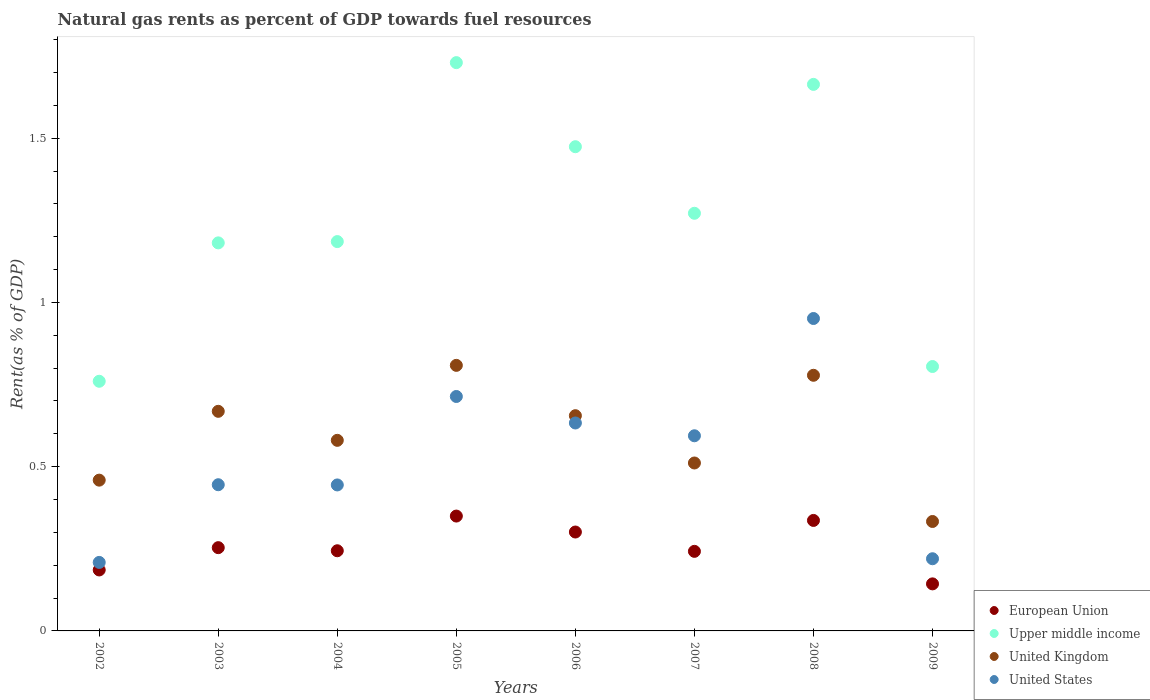How many different coloured dotlines are there?
Provide a succinct answer. 4. What is the matural gas rent in United Kingdom in 2004?
Give a very brief answer. 0.58. Across all years, what is the maximum matural gas rent in United Kingdom?
Ensure brevity in your answer.  0.81. Across all years, what is the minimum matural gas rent in European Union?
Your response must be concise. 0.14. What is the total matural gas rent in Upper middle income in the graph?
Offer a very short reply. 10.07. What is the difference between the matural gas rent in Upper middle income in 2006 and that in 2009?
Keep it short and to the point. 0.67. What is the difference between the matural gas rent in United States in 2002 and the matural gas rent in Upper middle income in 2003?
Provide a short and direct response. -0.97. What is the average matural gas rent in United Kingdom per year?
Offer a terse response. 0.6. In the year 2002, what is the difference between the matural gas rent in United States and matural gas rent in European Union?
Your answer should be very brief. 0.02. What is the ratio of the matural gas rent in United Kingdom in 2003 to that in 2009?
Offer a terse response. 2.01. Is the matural gas rent in United Kingdom in 2002 less than that in 2007?
Your answer should be very brief. Yes. What is the difference between the highest and the second highest matural gas rent in European Union?
Offer a terse response. 0.01. What is the difference between the highest and the lowest matural gas rent in United Kingdom?
Your answer should be very brief. 0.48. In how many years, is the matural gas rent in United States greater than the average matural gas rent in United States taken over all years?
Make the answer very short. 4. Is the sum of the matural gas rent in United States in 2002 and 2005 greater than the maximum matural gas rent in Upper middle income across all years?
Your answer should be compact. No. Is it the case that in every year, the sum of the matural gas rent in United States and matural gas rent in European Union  is greater than the sum of matural gas rent in United Kingdom and matural gas rent in Upper middle income?
Provide a short and direct response. No. Is it the case that in every year, the sum of the matural gas rent in Upper middle income and matural gas rent in European Union  is greater than the matural gas rent in United Kingdom?
Offer a very short reply. Yes. Does the matural gas rent in Upper middle income monotonically increase over the years?
Provide a succinct answer. No. Is the matural gas rent in United Kingdom strictly less than the matural gas rent in United States over the years?
Offer a very short reply. No. Are the values on the major ticks of Y-axis written in scientific E-notation?
Your answer should be compact. No. Where does the legend appear in the graph?
Provide a succinct answer. Bottom right. How many legend labels are there?
Give a very brief answer. 4. What is the title of the graph?
Offer a very short reply. Natural gas rents as percent of GDP towards fuel resources. Does "Guyana" appear as one of the legend labels in the graph?
Offer a very short reply. No. What is the label or title of the X-axis?
Give a very brief answer. Years. What is the label or title of the Y-axis?
Keep it short and to the point. Rent(as % of GDP). What is the Rent(as % of GDP) in European Union in 2002?
Offer a very short reply. 0.19. What is the Rent(as % of GDP) in Upper middle income in 2002?
Keep it short and to the point. 0.76. What is the Rent(as % of GDP) of United Kingdom in 2002?
Your response must be concise. 0.46. What is the Rent(as % of GDP) of United States in 2002?
Offer a terse response. 0.21. What is the Rent(as % of GDP) in European Union in 2003?
Your response must be concise. 0.25. What is the Rent(as % of GDP) in Upper middle income in 2003?
Offer a terse response. 1.18. What is the Rent(as % of GDP) of United Kingdom in 2003?
Provide a succinct answer. 0.67. What is the Rent(as % of GDP) in United States in 2003?
Provide a succinct answer. 0.45. What is the Rent(as % of GDP) of European Union in 2004?
Ensure brevity in your answer.  0.24. What is the Rent(as % of GDP) in Upper middle income in 2004?
Give a very brief answer. 1.19. What is the Rent(as % of GDP) of United Kingdom in 2004?
Make the answer very short. 0.58. What is the Rent(as % of GDP) of United States in 2004?
Offer a very short reply. 0.44. What is the Rent(as % of GDP) of European Union in 2005?
Keep it short and to the point. 0.35. What is the Rent(as % of GDP) of Upper middle income in 2005?
Your response must be concise. 1.73. What is the Rent(as % of GDP) of United Kingdom in 2005?
Offer a terse response. 0.81. What is the Rent(as % of GDP) of United States in 2005?
Provide a succinct answer. 0.71. What is the Rent(as % of GDP) in European Union in 2006?
Offer a very short reply. 0.3. What is the Rent(as % of GDP) in Upper middle income in 2006?
Provide a short and direct response. 1.47. What is the Rent(as % of GDP) in United Kingdom in 2006?
Offer a very short reply. 0.66. What is the Rent(as % of GDP) of United States in 2006?
Provide a succinct answer. 0.63. What is the Rent(as % of GDP) in European Union in 2007?
Offer a terse response. 0.24. What is the Rent(as % of GDP) in Upper middle income in 2007?
Provide a short and direct response. 1.27. What is the Rent(as % of GDP) of United Kingdom in 2007?
Ensure brevity in your answer.  0.51. What is the Rent(as % of GDP) of United States in 2007?
Make the answer very short. 0.59. What is the Rent(as % of GDP) of European Union in 2008?
Your response must be concise. 0.34. What is the Rent(as % of GDP) of Upper middle income in 2008?
Provide a short and direct response. 1.66. What is the Rent(as % of GDP) of United Kingdom in 2008?
Offer a very short reply. 0.78. What is the Rent(as % of GDP) in United States in 2008?
Give a very brief answer. 0.95. What is the Rent(as % of GDP) of European Union in 2009?
Your response must be concise. 0.14. What is the Rent(as % of GDP) of Upper middle income in 2009?
Keep it short and to the point. 0.8. What is the Rent(as % of GDP) of United Kingdom in 2009?
Give a very brief answer. 0.33. What is the Rent(as % of GDP) of United States in 2009?
Make the answer very short. 0.22. Across all years, what is the maximum Rent(as % of GDP) in European Union?
Provide a short and direct response. 0.35. Across all years, what is the maximum Rent(as % of GDP) of Upper middle income?
Make the answer very short. 1.73. Across all years, what is the maximum Rent(as % of GDP) of United Kingdom?
Give a very brief answer. 0.81. Across all years, what is the maximum Rent(as % of GDP) in United States?
Your answer should be compact. 0.95. Across all years, what is the minimum Rent(as % of GDP) in European Union?
Your answer should be compact. 0.14. Across all years, what is the minimum Rent(as % of GDP) of Upper middle income?
Make the answer very short. 0.76. Across all years, what is the minimum Rent(as % of GDP) of United Kingdom?
Your answer should be compact. 0.33. Across all years, what is the minimum Rent(as % of GDP) in United States?
Give a very brief answer. 0.21. What is the total Rent(as % of GDP) of European Union in the graph?
Provide a short and direct response. 2.06. What is the total Rent(as % of GDP) in Upper middle income in the graph?
Offer a very short reply. 10.07. What is the total Rent(as % of GDP) in United Kingdom in the graph?
Make the answer very short. 4.79. What is the total Rent(as % of GDP) in United States in the graph?
Ensure brevity in your answer.  4.21. What is the difference between the Rent(as % of GDP) in European Union in 2002 and that in 2003?
Ensure brevity in your answer.  -0.07. What is the difference between the Rent(as % of GDP) of Upper middle income in 2002 and that in 2003?
Offer a terse response. -0.42. What is the difference between the Rent(as % of GDP) in United Kingdom in 2002 and that in 2003?
Offer a terse response. -0.21. What is the difference between the Rent(as % of GDP) of United States in 2002 and that in 2003?
Your answer should be very brief. -0.24. What is the difference between the Rent(as % of GDP) of European Union in 2002 and that in 2004?
Keep it short and to the point. -0.06. What is the difference between the Rent(as % of GDP) in Upper middle income in 2002 and that in 2004?
Your answer should be compact. -0.43. What is the difference between the Rent(as % of GDP) of United Kingdom in 2002 and that in 2004?
Your answer should be very brief. -0.12. What is the difference between the Rent(as % of GDP) of United States in 2002 and that in 2004?
Offer a very short reply. -0.24. What is the difference between the Rent(as % of GDP) in European Union in 2002 and that in 2005?
Your response must be concise. -0.16. What is the difference between the Rent(as % of GDP) in Upper middle income in 2002 and that in 2005?
Ensure brevity in your answer.  -0.97. What is the difference between the Rent(as % of GDP) of United Kingdom in 2002 and that in 2005?
Give a very brief answer. -0.35. What is the difference between the Rent(as % of GDP) in United States in 2002 and that in 2005?
Provide a short and direct response. -0.51. What is the difference between the Rent(as % of GDP) of European Union in 2002 and that in 2006?
Provide a short and direct response. -0.12. What is the difference between the Rent(as % of GDP) of Upper middle income in 2002 and that in 2006?
Keep it short and to the point. -0.71. What is the difference between the Rent(as % of GDP) of United Kingdom in 2002 and that in 2006?
Give a very brief answer. -0.2. What is the difference between the Rent(as % of GDP) of United States in 2002 and that in 2006?
Provide a short and direct response. -0.42. What is the difference between the Rent(as % of GDP) in European Union in 2002 and that in 2007?
Your answer should be very brief. -0.06. What is the difference between the Rent(as % of GDP) in Upper middle income in 2002 and that in 2007?
Offer a terse response. -0.51. What is the difference between the Rent(as % of GDP) of United Kingdom in 2002 and that in 2007?
Provide a succinct answer. -0.05. What is the difference between the Rent(as % of GDP) of United States in 2002 and that in 2007?
Give a very brief answer. -0.39. What is the difference between the Rent(as % of GDP) in European Union in 2002 and that in 2008?
Your answer should be very brief. -0.15. What is the difference between the Rent(as % of GDP) of Upper middle income in 2002 and that in 2008?
Your answer should be very brief. -0.9. What is the difference between the Rent(as % of GDP) in United Kingdom in 2002 and that in 2008?
Offer a very short reply. -0.32. What is the difference between the Rent(as % of GDP) of United States in 2002 and that in 2008?
Provide a short and direct response. -0.74. What is the difference between the Rent(as % of GDP) in European Union in 2002 and that in 2009?
Give a very brief answer. 0.04. What is the difference between the Rent(as % of GDP) of Upper middle income in 2002 and that in 2009?
Make the answer very short. -0.04. What is the difference between the Rent(as % of GDP) of United Kingdom in 2002 and that in 2009?
Your answer should be very brief. 0.13. What is the difference between the Rent(as % of GDP) in United States in 2002 and that in 2009?
Provide a succinct answer. -0.01. What is the difference between the Rent(as % of GDP) in European Union in 2003 and that in 2004?
Keep it short and to the point. 0.01. What is the difference between the Rent(as % of GDP) in Upper middle income in 2003 and that in 2004?
Make the answer very short. -0. What is the difference between the Rent(as % of GDP) of United Kingdom in 2003 and that in 2004?
Offer a very short reply. 0.09. What is the difference between the Rent(as % of GDP) in United States in 2003 and that in 2004?
Provide a succinct answer. 0. What is the difference between the Rent(as % of GDP) in European Union in 2003 and that in 2005?
Your answer should be compact. -0.1. What is the difference between the Rent(as % of GDP) in Upper middle income in 2003 and that in 2005?
Make the answer very short. -0.55. What is the difference between the Rent(as % of GDP) in United Kingdom in 2003 and that in 2005?
Your answer should be compact. -0.14. What is the difference between the Rent(as % of GDP) in United States in 2003 and that in 2005?
Give a very brief answer. -0.27. What is the difference between the Rent(as % of GDP) in European Union in 2003 and that in 2006?
Provide a succinct answer. -0.05. What is the difference between the Rent(as % of GDP) of Upper middle income in 2003 and that in 2006?
Ensure brevity in your answer.  -0.29. What is the difference between the Rent(as % of GDP) of United Kingdom in 2003 and that in 2006?
Offer a very short reply. 0.01. What is the difference between the Rent(as % of GDP) in United States in 2003 and that in 2006?
Your answer should be compact. -0.19. What is the difference between the Rent(as % of GDP) in European Union in 2003 and that in 2007?
Make the answer very short. 0.01. What is the difference between the Rent(as % of GDP) in Upper middle income in 2003 and that in 2007?
Ensure brevity in your answer.  -0.09. What is the difference between the Rent(as % of GDP) of United Kingdom in 2003 and that in 2007?
Your answer should be compact. 0.16. What is the difference between the Rent(as % of GDP) of United States in 2003 and that in 2007?
Ensure brevity in your answer.  -0.15. What is the difference between the Rent(as % of GDP) of European Union in 2003 and that in 2008?
Offer a terse response. -0.08. What is the difference between the Rent(as % of GDP) of Upper middle income in 2003 and that in 2008?
Ensure brevity in your answer.  -0.48. What is the difference between the Rent(as % of GDP) of United Kingdom in 2003 and that in 2008?
Your answer should be compact. -0.11. What is the difference between the Rent(as % of GDP) of United States in 2003 and that in 2008?
Offer a terse response. -0.51. What is the difference between the Rent(as % of GDP) of European Union in 2003 and that in 2009?
Provide a short and direct response. 0.11. What is the difference between the Rent(as % of GDP) in Upper middle income in 2003 and that in 2009?
Keep it short and to the point. 0.38. What is the difference between the Rent(as % of GDP) in United Kingdom in 2003 and that in 2009?
Provide a short and direct response. 0.34. What is the difference between the Rent(as % of GDP) of United States in 2003 and that in 2009?
Offer a very short reply. 0.23. What is the difference between the Rent(as % of GDP) in European Union in 2004 and that in 2005?
Provide a short and direct response. -0.11. What is the difference between the Rent(as % of GDP) in Upper middle income in 2004 and that in 2005?
Give a very brief answer. -0.54. What is the difference between the Rent(as % of GDP) of United Kingdom in 2004 and that in 2005?
Keep it short and to the point. -0.23. What is the difference between the Rent(as % of GDP) of United States in 2004 and that in 2005?
Your answer should be compact. -0.27. What is the difference between the Rent(as % of GDP) of European Union in 2004 and that in 2006?
Your answer should be compact. -0.06. What is the difference between the Rent(as % of GDP) in Upper middle income in 2004 and that in 2006?
Make the answer very short. -0.29. What is the difference between the Rent(as % of GDP) of United Kingdom in 2004 and that in 2006?
Make the answer very short. -0.07. What is the difference between the Rent(as % of GDP) in United States in 2004 and that in 2006?
Your response must be concise. -0.19. What is the difference between the Rent(as % of GDP) in European Union in 2004 and that in 2007?
Keep it short and to the point. 0. What is the difference between the Rent(as % of GDP) of Upper middle income in 2004 and that in 2007?
Provide a succinct answer. -0.09. What is the difference between the Rent(as % of GDP) in United Kingdom in 2004 and that in 2007?
Provide a short and direct response. 0.07. What is the difference between the Rent(as % of GDP) of United States in 2004 and that in 2007?
Offer a very short reply. -0.15. What is the difference between the Rent(as % of GDP) in European Union in 2004 and that in 2008?
Offer a terse response. -0.09. What is the difference between the Rent(as % of GDP) in Upper middle income in 2004 and that in 2008?
Give a very brief answer. -0.48. What is the difference between the Rent(as % of GDP) in United Kingdom in 2004 and that in 2008?
Provide a succinct answer. -0.2. What is the difference between the Rent(as % of GDP) of United States in 2004 and that in 2008?
Make the answer very short. -0.51. What is the difference between the Rent(as % of GDP) in European Union in 2004 and that in 2009?
Give a very brief answer. 0.1. What is the difference between the Rent(as % of GDP) of Upper middle income in 2004 and that in 2009?
Give a very brief answer. 0.38. What is the difference between the Rent(as % of GDP) of United Kingdom in 2004 and that in 2009?
Ensure brevity in your answer.  0.25. What is the difference between the Rent(as % of GDP) of United States in 2004 and that in 2009?
Offer a terse response. 0.22. What is the difference between the Rent(as % of GDP) of European Union in 2005 and that in 2006?
Provide a short and direct response. 0.05. What is the difference between the Rent(as % of GDP) in Upper middle income in 2005 and that in 2006?
Provide a short and direct response. 0.26. What is the difference between the Rent(as % of GDP) in United Kingdom in 2005 and that in 2006?
Offer a terse response. 0.15. What is the difference between the Rent(as % of GDP) of United States in 2005 and that in 2006?
Provide a short and direct response. 0.08. What is the difference between the Rent(as % of GDP) of European Union in 2005 and that in 2007?
Your answer should be compact. 0.11. What is the difference between the Rent(as % of GDP) of Upper middle income in 2005 and that in 2007?
Ensure brevity in your answer.  0.46. What is the difference between the Rent(as % of GDP) of United Kingdom in 2005 and that in 2007?
Make the answer very short. 0.3. What is the difference between the Rent(as % of GDP) of United States in 2005 and that in 2007?
Keep it short and to the point. 0.12. What is the difference between the Rent(as % of GDP) of European Union in 2005 and that in 2008?
Give a very brief answer. 0.01. What is the difference between the Rent(as % of GDP) in Upper middle income in 2005 and that in 2008?
Ensure brevity in your answer.  0.07. What is the difference between the Rent(as % of GDP) of United Kingdom in 2005 and that in 2008?
Your answer should be very brief. 0.03. What is the difference between the Rent(as % of GDP) of United States in 2005 and that in 2008?
Your response must be concise. -0.24. What is the difference between the Rent(as % of GDP) of European Union in 2005 and that in 2009?
Ensure brevity in your answer.  0.21. What is the difference between the Rent(as % of GDP) in Upper middle income in 2005 and that in 2009?
Keep it short and to the point. 0.93. What is the difference between the Rent(as % of GDP) of United Kingdom in 2005 and that in 2009?
Your response must be concise. 0.48. What is the difference between the Rent(as % of GDP) in United States in 2005 and that in 2009?
Provide a short and direct response. 0.49. What is the difference between the Rent(as % of GDP) in European Union in 2006 and that in 2007?
Offer a terse response. 0.06. What is the difference between the Rent(as % of GDP) of Upper middle income in 2006 and that in 2007?
Your answer should be compact. 0.2. What is the difference between the Rent(as % of GDP) in United Kingdom in 2006 and that in 2007?
Provide a succinct answer. 0.14. What is the difference between the Rent(as % of GDP) in United States in 2006 and that in 2007?
Offer a terse response. 0.04. What is the difference between the Rent(as % of GDP) of European Union in 2006 and that in 2008?
Provide a short and direct response. -0.04. What is the difference between the Rent(as % of GDP) of Upper middle income in 2006 and that in 2008?
Offer a very short reply. -0.19. What is the difference between the Rent(as % of GDP) of United Kingdom in 2006 and that in 2008?
Provide a short and direct response. -0.12. What is the difference between the Rent(as % of GDP) in United States in 2006 and that in 2008?
Make the answer very short. -0.32. What is the difference between the Rent(as % of GDP) in European Union in 2006 and that in 2009?
Offer a terse response. 0.16. What is the difference between the Rent(as % of GDP) of Upper middle income in 2006 and that in 2009?
Offer a terse response. 0.67. What is the difference between the Rent(as % of GDP) in United Kingdom in 2006 and that in 2009?
Make the answer very short. 0.32. What is the difference between the Rent(as % of GDP) in United States in 2006 and that in 2009?
Offer a terse response. 0.41. What is the difference between the Rent(as % of GDP) in European Union in 2007 and that in 2008?
Keep it short and to the point. -0.09. What is the difference between the Rent(as % of GDP) of Upper middle income in 2007 and that in 2008?
Your response must be concise. -0.39. What is the difference between the Rent(as % of GDP) in United Kingdom in 2007 and that in 2008?
Your response must be concise. -0.27. What is the difference between the Rent(as % of GDP) in United States in 2007 and that in 2008?
Your response must be concise. -0.36. What is the difference between the Rent(as % of GDP) of European Union in 2007 and that in 2009?
Ensure brevity in your answer.  0.1. What is the difference between the Rent(as % of GDP) in Upper middle income in 2007 and that in 2009?
Your answer should be compact. 0.47. What is the difference between the Rent(as % of GDP) in United Kingdom in 2007 and that in 2009?
Provide a succinct answer. 0.18. What is the difference between the Rent(as % of GDP) of United States in 2007 and that in 2009?
Ensure brevity in your answer.  0.37. What is the difference between the Rent(as % of GDP) of European Union in 2008 and that in 2009?
Keep it short and to the point. 0.19. What is the difference between the Rent(as % of GDP) in Upper middle income in 2008 and that in 2009?
Your response must be concise. 0.86. What is the difference between the Rent(as % of GDP) in United Kingdom in 2008 and that in 2009?
Ensure brevity in your answer.  0.45. What is the difference between the Rent(as % of GDP) of United States in 2008 and that in 2009?
Your answer should be compact. 0.73. What is the difference between the Rent(as % of GDP) of European Union in 2002 and the Rent(as % of GDP) of Upper middle income in 2003?
Provide a short and direct response. -1. What is the difference between the Rent(as % of GDP) in European Union in 2002 and the Rent(as % of GDP) in United Kingdom in 2003?
Make the answer very short. -0.48. What is the difference between the Rent(as % of GDP) of European Union in 2002 and the Rent(as % of GDP) of United States in 2003?
Ensure brevity in your answer.  -0.26. What is the difference between the Rent(as % of GDP) in Upper middle income in 2002 and the Rent(as % of GDP) in United Kingdom in 2003?
Provide a succinct answer. 0.09. What is the difference between the Rent(as % of GDP) in Upper middle income in 2002 and the Rent(as % of GDP) in United States in 2003?
Provide a short and direct response. 0.32. What is the difference between the Rent(as % of GDP) of United Kingdom in 2002 and the Rent(as % of GDP) of United States in 2003?
Your response must be concise. 0.01. What is the difference between the Rent(as % of GDP) of European Union in 2002 and the Rent(as % of GDP) of Upper middle income in 2004?
Keep it short and to the point. -1. What is the difference between the Rent(as % of GDP) of European Union in 2002 and the Rent(as % of GDP) of United Kingdom in 2004?
Make the answer very short. -0.39. What is the difference between the Rent(as % of GDP) in European Union in 2002 and the Rent(as % of GDP) in United States in 2004?
Keep it short and to the point. -0.26. What is the difference between the Rent(as % of GDP) of Upper middle income in 2002 and the Rent(as % of GDP) of United Kingdom in 2004?
Keep it short and to the point. 0.18. What is the difference between the Rent(as % of GDP) in Upper middle income in 2002 and the Rent(as % of GDP) in United States in 2004?
Provide a short and direct response. 0.32. What is the difference between the Rent(as % of GDP) in United Kingdom in 2002 and the Rent(as % of GDP) in United States in 2004?
Your answer should be very brief. 0.01. What is the difference between the Rent(as % of GDP) of European Union in 2002 and the Rent(as % of GDP) of Upper middle income in 2005?
Ensure brevity in your answer.  -1.54. What is the difference between the Rent(as % of GDP) in European Union in 2002 and the Rent(as % of GDP) in United Kingdom in 2005?
Provide a succinct answer. -0.62. What is the difference between the Rent(as % of GDP) of European Union in 2002 and the Rent(as % of GDP) of United States in 2005?
Make the answer very short. -0.53. What is the difference between the Rent(as % of GDP) in Upper middle income in 2002 and the Rent(as % of GDP) in United Kingdom in 2005?
Provide a succinct answer. -0.05. What is the difference between the Rent(as % of GDP) of Upper middle income in 2002 and the Rent(as % of GDP) of United States in 2005?
Your answer should be compact. 0.05. What is the difference between the Rent(as % of GDP) in United Kingdom in 2002 and the Rent(as % of GDP) in United States in 2005?
Offer a terse response. -0.25. What is the difference between the Rent(as % of GDP) in European Union in 2002 and the Rent(as % of GDP) in Upper middle income in 2006?
Your answer should be compact. -1.29. What is the difference between the Rent(as % of GDP) in European Union in 2002 and the Rent(as % of GDP) in United Kingdom in 2006?
Your answer should be compact. -0.47. What is the difference between the Rent(as % of GDP) in European Union in 2002 and the Rent(as % of GDP) in United States in 2006?
Make the answer very short. -0.45. What is the difference between the Rent(as % of GDP) in Upper middle income in 2002 and the Rent(as % of GDP) in United Kingdom in 2006?
Provide a succinct answer. 0.1. What is the difference between the Rent(as % of GDP) of Upper middle income in 2002 and the Rent(as % of GDP) of United States in 2006?
Your answer should be very brief. 0.13. What is the difference between the Rent(as % of GDP) in United Kingdom in 2002 and the Rent(as % of GDP) in United States in 2006?
Your answer should be compact. -0.17. What is the difference between the Rent(as % of GDP) of European Union in 2002 and the Rent(as % of GDP) of Upper middle income in 2007?
Your answer should be compact. -1.09. What is the difference between the Rent(as % of GDP) of European Union in 2002 and the Rent(as % of GDP) of United Kingdom in 2007?
Offer a very short reply. -0.33. What is the difference between the Rent(as % of GDP) of European Union in 2002 and the Rent(as % of GDP) of United States in 2007?
Provide a succinct answer. -0.41. What is the difference between the Rent(as % of GDP) of Upper middle income in 2002 and the Rent(as % of GDP) of United Kingdom in 2007?
Offer a very short reply. 0.25. What is the difference between the Rent(as % of GDP) in Upper middle income in 2002 and the Rent(as % of GDP) in United States in 2007?
Make the answer very short. 0.17. What is the difference between the Rent(as % of GDP) in United Kingdom in 2002 and the Rent(as % of GDP) in United States in 2007?
Offer a very short reply. -0.14. What is the difference between the Rent(as % of GDP) of European Union in 2002 and the Rent(as % of GDP) of Upper middle income in 2008?
Keep it short and to the point. -1.48. What is the difference between the Rent(as % of GDP) in European Union in 2002 and the Rent(as % of GDP) in United Kingdom in 2008?
Provide a short and direct response. -0.59. What is the difference between the Rent(as % of GDP) in European Union in 2002 and the Rent(as % of GDP) in United States in 2008?
Your answer should be compact. -0.77. What is the difference between the Rent(as % of GDP) in Upper middle income in 2002 and the Rent(as % of GDP) in United Kingdom in 2008?
Your response must be concise. -0.02. What is the difference between the Rent(as % of GDP) of Upper middle income in 2002 and the Rent(as % of GDP) of United States in 2008?
Provide a short and direct response. -0.19. What is the difference between the Rent(as % of GDP) in United Kingdom in 2002 and the Rent(as % of GDP) in United States in 2008?
Keep it short and to the point. -0.49. What is the difference between the Rent(as % of GDP) in European Union in 2002 and the Rent(as % of GDP) in Upper middle income in 2009?
Offer a terse response. -0.62. What is the difference between the Rent(as % of GDP) of European Union in 2002 and the Rent(as % of GDP) of United Kingdom in 2009?
Provide a short and direct response. -0.15. What is the difference between the Rent(as % of GDP) in European Union in 2002 and the Rent(as % of GDP) in United States in 2009?
Ensure brevity in your answer.  -0.03. What is the difference between the Rent(as % of GDP) of Upper middle income in 2002 and the Rent(as % of GDP) of United Kingdom in 2009?
Offer a terse response. 0.43. What is the difference between the Rent(as % of GDP) in Upper middle income in 2002 and the Rent(as % of GDP) in United States in 2009?
Offer a very short reply. 0.54. What is the difference between the Rent(as % of GDP) of United Kingdom in 2002 and the Rent(as % of GDP) of United States in 2009?
Your answer should be compact. 0.24. What is the difference between the Rent(as % of GDP) in European Union in 2003 and the Rent(as % of GDP) in Upper middle income in 2004?
Offer a very short reply. -0.93. What is the difference between the Rent(as % of GDP) of European Union in 2003 and the Rent(as % of GDP) of United Kingdom in 2004?
Keep it short and to the point. -0.33. What is the difference between the Rent(as % of GDP) in European Union in 2003 and the Rent(as % of GDP) in United States in 2004?
Provide a short and direct response. -0.19. What is the difference between the Rent(as % of GDP) of Upper middle income in 2003 and the Rent(as % of GDP) of United Kingdom in 2004?
Make the answer very short. 0.6. What is the difference between the Rent(as % of GDP) in Upper middle income in 2003 and the Rent(as % of GDP) in United States in 2004?
Provide a succinct answer. 0.74. What is the difference between the Rent(as % of GDP) in United Kingdom in 2003 and the Rent(as % of GDP) in United States in 2004?
Your answer should be very brief. 0.22. What is the difference between the Rent(as % of GDP) in European Union in 2003 and the Rent(as % of GDP) in Upper middle income in 2005?
Your response must be concise. -1.48. What is the difference between the Rent(as % of GDP) in European Union in 2003 and the Rent(as % of GDP) in United Kingdom in 2005?
Keep it short and to the point. -0.56. What is the difference between the Rent(as % of GDP) of European Union in 2003 and the Rent(as % of GDP) of United States in 2005?
Your response must be concise. -0.46. What is the difference between the Rent(as % of GDP) in Upper middle income in 2003 and the Rent(as % of GDP) in United Kingdom in 2005?
Provide a succinct answer. 0.37. What is the difference between the Rent(as % of GDP) of Upper middle income in 2003 and the Rent(as % of GDP) of United States in 2005?
Ensure brevity in your answer.  0.47. What is the difference between the Rent(as % of GDP) of United Kingdom in 2003 and the Rent(as % of GDP) of United States in 2005?
Offer a very short reply. -0.05. What is the difference between the Rent(as % of GDP) of European Union in 2003 and the Rent(as % of GDP) of Upper middle income in 2006?
Offer a very short reply. -1.22. What is the difference between the Rent(as % of GDP) in European Union in 2003 and the Rent(as % of GDP) in United Kingdom in 2006?
Give a very brief answer. -0.4. What is the difference between the Rent(as % of GDP) of European Union in 2003 and the Rent(as % of GDP) of United States in 2006?
Provide a succinct answer. -0.38. What is the difference between the Rent(as % of GDP) of Upper middle income in 2003 and the Rent(as % of GDP) of United Kingdom in 2006?
Make the answer very short. 0.53. What is the difference between the Rent(as % of GDP) in Upper middle income in 2003 and the Rent(as % of GDP) in United States in 2006?
Offer a terse response. 0.55. What is the difference between the Rent(as % of GDP) in United Kingdom in 2003 and the Rent(as % of GDP) in United States in 2006?
Provide a succinct answer. 0.04. What is the difference between the Rent(as % of GDP) of European Union in 2003 and the Rent(as % of GDP) of Upper middle income in 2007?
Give a very brief answer. -1.02. What is the difference between the Rent(as % of GDP) in European Union in 2003 and the Rent(as % of GDP) in United Kingdom in 2007?
Your answer should be compact. -0.26. What is the difference between the Rent(as % of GDP) of European Union in 2003 and the Rent(as % of GDP) of United States in 2007?
Your answer should be very brief. -0.34. What is the difference between the Rent(as % of GDP) in Upper middle income in 2003 and the Rent(as % of GDP) in United Kingdom in 2007?
Offer a terse response. 0.67. What is the difference between the Rent(as % of GDP) in Upper middle income in 2003 and the Rent(as % of GDP) in United States in 2007?
Ensure brevity in your answer.  0.59. What is the difference between the Rent(as % of GDP) of United Kingdom in 2003 and the Rent(as % of GDP) of United States in 2007?
Provide a succinct answer. 0.07. What is the difference between the Rent(as % of GDP) of European Union in 2003 and the Rent(as % of GDP) of Upper middle income in 2008?
Your response must be concise. -1.41. What is the difference between the Rent(as % of GDP) in European Union in 2003 and the Rent(as % of GDP) in United Kingdom in 2008?
Make the answer very short. -0.52. What is the difference between the Rent(as % of GDP) of European Union in 2003 and the Rent(as % of GDP) of United States in 2008?
Your answer should be very brief. -0.7. What is the difference between the Rent(as % of GDP) of Upper middle income in 2003 and the Rent(as % of GDP) of United Kingdom in 2008?
Offer a very short reply. 0.4. What is the difference between the Rent(as % of GDP) of Upper middle income in 2003 and the Rent(as % of GDP) of United States in 2008?
Offer a terse response. 0.23. What is the difference between the Rent(as % of GDP) in United Kingdom in 2003 and the Rent(as % of GDP) in United States in 2008?
Your response must be concise. -0.28. What is the difference between the Rent(as % of GDP) of European Union in 2003 and the Rent(as % of GDP) of Upper middle income in 2009?
Ensure brevity in your answer.  -0.55. What is the difference between the Rent(as % of GDP) in European Union in 2003 and the Rent(as % of GDP) in United Kingdom in 2009?
Your answer should be compact. -0.08. What is the difference between the Rent(as % of GDP) in European Union in 2003 and the Rent(as % of GDP) in United States in 2009?
Ensure brevity in your answer.  0.03. What is the difference between the Rent(as % of GDP) of Upper middle income in 2003 and the Rent(as % of GDP) of United Kingdom in 2009?
Provide a short and direct response. 0.85. What is the difference between the Rent(as % of GDP) in Upper middle income in 2003 and the Rent(as % of GDP) in United States in 2009?
Give a very brief answer. 0.96. What is the difference between the Rent(as % of GDP) in United Kingdom in 2003 and the Rent(as % of GDP) in United States in 2009?
Provide a short and direct response. 0.45. What is the difference between the Rent(as % of GDP) of European Union in 2004 and the Rent(as % of GDP) of Upper middle income in 2005?
Your response must be concise. -1.49. What is the difference between the Rent(as % of GDP) in European Union in 2004 and the Rent(as % of GDP) in United Kingdom in 2005?
Your response must be concise. -0.56. What is the difference between the Rent(as % of GDP) in European Union in 2004 and the Rent(as % of GDP) in United States in 2005?
Make the answer very short. -0.47. What is the difference between the Rent(as % of GDP) of Upper middle income in 2004 and the Rent(as % of GDP) of United Kingdom in 2005?
Provide a short and direct response. 0.38. What is the difference between the Rent(as % of GDP) in Upper middle income in 2004 and the Rent(as % of GDP) in United States in 2005?
Keep it short and to the point. 0.47. What is the difference between the Rent(as % of GDP) in United Kingdom in 2004 and the Rent(as % of GDP) in United States in 2005?
Your answer should be compact. -0.13. What is the difference between the Rent(as % of GDP) in European Union in 2004 and the Rent(as % of GDP) in Upper middle income in 2006?
Keep it short and to the point. -1.23. What is the difference between the Rent(as % of GDP) in European Union in 2004 and the Rent(as % of GDP) in United Kingdom in 2006?
Offer a very short reply. -0.41. What is the difference between the Rent(as % of GDP) in European Union in 2004 and the Rent(as % of GDP) in United States in 2006?
Offer a terse response. -0.39. What is the difference between the Rent(as % of GDP) of Upper middle income in 2004 and the Rent(as % of GDP) of United Kingdom in 2006?
Give a very brief answer. 0.53. What is the difference between the Rent(as % of GDP) of Upper middle income in 2004 and the Rent(as % of GDP) of United States in 2006?
Make the answer very short. 0.55. What is the difference between the Rent(as % of GDP) in United Kingdom in 2004 and the Rent(as % of GDP) in United States in 2006?
Give a very brief answer. -0.05. What is the difference between the Rent(as % of GDP) in European Union in 2004 and the Rent(as % of GDP) in Upper middle income in 2007?
Ensure brevity in your answer.  -1.03. What is the difference between the Rent(as % of GDP) in European Union in 2004 and the Rent(as % of GDP) in United Kingdom in 2007?
Make the answer very short. -0.27. What is the difference between the Rent(as % of GDP) of European Union in 2004 and the Rent(as % of GDP) of United States in 2007?
Keep it short and to the point. -0.35. What is the difference between the Rent(as % of GDP) of Upper middle income in 2004 and the Rent(as % of GDP) of United Kingdom in 2007?
Give a very brief answer. 0.67. What is the difference between the Rent(as % of GDP) of Upper middle income in 2004 and the Rent(as % of GDP) of United States in 2007?
Give a very brief answer. 0.59. What is the difference between the Rent(as % of GDP) of United Kingdom in 2004 and the Rent(as % of GDP) of United States in 2007?
Your answer should be compact. -0.01. What is the difference between the Rent(as % of GDP) of European Union in 2004 and the Rent(as % of GDP) of Upper middle income in 2008?
Provide a succinct answer. -1.42. What is the difference between the Rent(as % of GDP) of European Union in 2004 and the Rent(as % of GDP) of United Kingdom in 2008?
Make the answer very short. -0.53. What is the difference between the Rent(as % of GDP) in European Union in 2004 and the Rent(as % of GDP) in United States in 2008?
Provide a succinct answer. -0.71. What is the difference between the Rent(as % of GDP) of Upper middle income in 2004 and the Rent(as % of GDP) of United Kingdom in 2008?
Provide a short and direct response. 0.41. What is the difference between the Rent(as % of GDP) in Upper middle income in 2004 and the Rent(as % of GDP) in United States in 2008?
Offer a very short reply. 0.23. What is the difference between the Rent(as % of GDP) of United Kingdom in 2004 and the Rent(as % of GDP) of United States in 2008?
Give a very brief answer. -0.37. What is the difference between the Rent(as % of GDP) in European Union in 2004 and the Rent(as % of GDP) in Upper middle income in 2009?
Give a very brief answer. -0.56. What is the difference between the Rent(as % of GDP) in European Union in 2004 and the Rent(as % of GDP) in United Kingdom in 2009?
Your response must be concise. -0.09. What is the difference between the Rent(as % of GDP) in European Union in 2004 and the Rent(as % of GDP) in United States in 2009?
Keep it short and to the point. 0.02. What is the difference between the Rent(as % of GDP) in Upper middle income in 2004 and the Rent(as % of GDP) in United Kingdom in 2009?
Provide a succinct answer. 0.85. What is the difference between the Rent(as % of GDP) of Upper middle income in 2004 and the Rent(as % of GDP) of United States in 2009?
Make the answer very short. 0.97. What is the difference between the Rent(as % of GDP) of United Kingdom in 2004 and the Rent(as % of GDP) of United States in 2009?
Give a very brief answer. 0.36. What is the difference between the Rent(as % of GDP) of European Union in 2005 and the Rent(as % of GDP) of Upper middle income in 2006?
Keep it short and to the point. -1.12. What is the difference between the Rent(as % of GDP) of European Union in 2005 and the Rent(as % of GDP) of United Kingdom in 2006?
Provide a succinct answer. -0.31. What is the difference between the Rent(as % of GDP) in European Union in 2005 and the Rent(as % of GDP) in United States in 2006?
Give a very brief answer. -0.28. What is the difference between the Rent(as % of GDP) of Upper middle income in 2005 and the Rent(as % of GDP) of United Kingdom in 2006?
Offer a very short reply. 1.07. What is the difference between the Rent(as % of GDP) of Upper middle income in 2005 and the Rent(as % of GDP) of United States in 2006?
Your response must be concise. 1.1. What is the difference between the Rent(as % of GDP) in United Kingdom in 2005 and the Rent(as % of GDP) in United States in 2006?
Make the answer very short. 0.18. What is the difference between the Rent(as % of GDP) in European Union in 2005 and the Rent(as % of GDP) in Upper middle income in 2007?
Offer a terse response. -0.92. What is the difference between the Rent(as % of GDP) in European Union in 2005 and the Rent(as % of GDP) in United Kingdom in 2007?
Give a very brief answer. -0.16. What is the difference between the Rent(as % of GDP) in European Union in 2005 and the Rent(as % of GDP) in United States in 2007?
Make the answer very short. -0.24. What is the difference between the Rent(as % of GDP) in Upper middle income in 2005 and the Rent(as % of GDP) in United Kingdom in 2007?
Provide a succinct answer. 1.22. What is the difference between the Rent(as % of GDP) in Upper middle income in 2005 and the Rent(as % of GDP) in United States in 2007?
Offer a very short reply. 1.14. What is the difference between the Rent(as % of GDP) of United Kingdom in 2005 and the Rent(as % of GDP) of United States in 2007?
Make the answer very short. 0.21. What is the difference between the Rent(as % of GDP) of European Union in 2005 and the Rent(as % of GDP) of Upper middle income in 2008?
Give a very brief answer. -1.31. What is the difference between the Rent(as % of GDP) in European Union in 2005 and the Rent(as % of GDP) in United Kingdom in 2008?
Your answer should be very brief. -0.43. What is the difference between the Rent(as % of GDP) of European Union in 2005 and the Rent(as % of GDP) of United States in 2008?
Your answer should be compact. -0.6. What is the difference between the Rent(as % of GDP) in Upper middle income in 2005 and the Rent(as % of GDP) in United Kingdom in 2008?
Provide a short and direct response. 0.95. What is the difference between the Rent(as % of GDP) of Upper middle income in 2005 and the Rent(as % of GDP) of United States in 2008?
Your response must be concise. 0.78. What is the difference between the Rent(as % of GDP) in United Kingdom in 2005 and the Rent(as % of GDP) in United States in 2008?
Make the answer very short. -0.14. What is the difference between the Rent(as % of GDP) in European Union in 2005 and the Rent(as % of GDP) in Upper middle income in 2009?
Your answer should be compact. -0.46. What is the difference between the Rent(as % of GDP) in European Union in 2005 and the Rent(as % of GDP) in United Kingdom in 2009?
Your answer should be very brief. 0.02. What is the difference between the Rent(as % of GDP) of European Union in 2005 and the Rent(as % of GDP) of United States in 2009?
Your answer should be very brief. 0.13. What is the difference between the Rent(as % of GDP) in Upper middle income in 2005 and the Rent(as % of GDP) in United Kingdom in 2009?
Your response must be concise. 1.4. What is the difference between the Rent(as % of GDP) of Upper middle income in 2005 and the Rent(as % of GDP) of United States in 2009?
Give a very brief answer. 1.51. What is the difference between the Rent(as % of GDP) in United Kingdom in 2005 and the Rent(as % of GDP) in United States in 2009?
Your response must be concise. 0.59. What is the difference between the Rent(as % of GDP) of European Union in 2006 and the Rent(as % of GDP) of Upper middle income in 2007?
Provide a succinct answer. -0.97. What is the difference between the Rent(as % of GDP) of European Union in 2006 and the Rent(as % of GDP) of United Kingdom in 2007?
Give a very brief answer. -0.21. What is the difference between the Rent(as % of GDP) in European Union in 2006 and the Rent(as % of GDP) in United States in 2007?
Make the answer very short. -0.29. What is the difference between the Rent(as % of GDP) in Upper middle income in 2006 and the Rent(as % of GDP) in United Kingdom in 2007?
Provide a short and direct response. 0.96. What is the difference between the Rent(as % of GDP) in Upper middle income in 2006 and the Rent(as % of GDP) in United States in 2007?
Ensure brevity in your answer.  0.88. What is the difference between the Rent(as % of GDP) of United Kingdom in 2006 and the Rent(as % of GDP) of United States in 2007?
Keep it short and to the point. 0.06. What is the difference between the Rent(as % of GDP) in European Union in 2006 and the Rent(as % of GDP) in Upper middle income in 2008?
Keep it short and to the point. -1.36. What is the difference between the Rent(as % of GDP) in European Union in 2006 and the Rent(as % of GDP) in United Kingdom in 2008?
Your answer should be compact. -0.48. What is the difference between the Rent(as % of GDP) of European Union in 2006 and the Rent(as % of GDP) of United States in 2008?
Provide a short and direct response. -0.65. What is the difference between the Rent(as % of GDP) of Upper middle income in 2006 and the Rent(as % of GDP) of United Kingdom in 2008?
Provide a short and direct response. 0.7. What is the difference between the Rent(as % of GDP) in Upper middle income in 2006 and the Rent(as % of GDP) in United States in 2008?
Give a very brief answer. 0.52. What is the difference between the Rent(as % of GDP) of United Kingdom in 2006 and the Rent(as % of GDP) of United States in 2008?
Ensure brevity in your answer.  -0.3. What is the difference between the Rent(as % of GDP) in European Union in 2006 and the Rent(as % of GDP) in Upper middle income in 2009?
Provide a succinct answer. -0.5. What is the difference between the Rent(as % of GDP) in European Union in 2006 and the Rent(as % of GDP) in United Kingdom in 2009?
Offer a very short reply. -0.03. What is the difference between the Rent(as % of GDP) of European Union in 2006 and the Rent(as % of GDP) of United States in 2009?
Provide a short and direct response. 0.08. What is the difference between the Rent(as % of GDP) in Upper middle income in 2006 and the Rent(as % of GDP) in United Kingdom in 2009?
Offer a terse response. 1.14. What is the difference between the Rent(as % of GDP) in Upper middle income in 2006 and the Rent(as % of GDP) in United States in 2009?
Give a very brief answer. 1.25. What is the difference between the Rent(as % of GDP) in United Kingdom in 2006 and the Rent(as % of GDP) in United States in 2009?
Ensure brevity in your answer.  0.44. What is the difference between the Rent(as % of GDP) in European Union in 2007 and the Rent(as % of GDP) in Upper middle income in 2008?
Make the answer very short. -1.42. What is the difference between the Rent(as % of GDP) in European Union in 2007 and the Rent(as % of GDP) in United Kingdom in 2008?
Give a very brief answer. -0.54. What is the difference between the Rent(as % of GDP) of European Union in 2007 and the Rent(as % of GDP) of United States in 2008?
Offer a very short reply. -0.71. What is the difference between the Rent(as % of GDP) in Upper middle income in 2007 and the Rent(as % of GDP) in United Kingdom in 2008?
Your answer should be compact. 0.49. What is the difference between the Rent(as % of GDP) in Upper middle income in 2007 and the Rent(as % of GDP) in United States in 2008?
Ensure brevity in your answer.  0.32. What is the difference between the Rent(as % of GDP) in United Kingdom in 2007 and the Rent(as % of GDP) in United States in 2008?
Ensure brevity in your answer.  -0.44. What is the difference between the Rent(as % of GDP) in European Union in 2007 and the Rent(as % of GDP) in Upper middle income in 2009?
Your answer should be very brief. -0.56. What is the difference between the Rent(as % of GDP) of European Union in 2007 and the Rent(as % of GDP) of United Kingdom in 2009?
Your response must be concise. -0.09. What is the difference between the Rent(as % of GDP) in European Union in 2007 and the Rent(as % of GDP) in United States in 2009?
Provide a succinct answer. 0.02. What is the difference between the Rent(as % of GDP) of Upper middle income in 2007 and the Rent(as % of GDP) of United Kingdom in 2009?
Provide a short and direct response. 0.94. What is the difference between the Rent(as % of GDP) of Upper middle income in 2007 and the Rent(as % of GDP) of United States in 2009?
Your answer should be very brief. 1.05. What is the difference between the Rent(as % of GDP) in United Kingdom in 2007 and the Rent(as % of GDP) in United States in 2009?
Offer a very short reply. 0.29. What is the difference between the Rent(as % of GDP) of European Union in 2008 and the Rent(as % of GDP) of Upper middle income in 2009?
Your response must be concise. -0.47. What is the difference between the Rent(as % of GDP) of European Union in 2008 and the Rent(as % of GDP) of United Kingdom in 2009?
Keep it short and to the point. 0. What is the difference between the Rent(as % of GDP) of European Union in 2008 and the Rent(as % of GDP) of United States in 2009?
Offer a terse response. 0.12. What is the difference between the Rent(as % of GDP) of Upper middle income in 2008 and the Rent(as % of GDP) of United Kingdom in 2009?
Your answer should be very brief. 1.33. What is the difference between the Rent(as % of GDP) in Upper middle income in 2008 and the Rent(as % of GDP) in United States in 2009?
Provide a short and direct response. 1.44. What is the difference between the Rent(as % of GDP) in United Kingdom in 2008 and the Rent(as % of GDP) in United States in 2009?
Offer a very short reply. 0.56. What is the average Rent(as % of GDP) in European Union per year?
Give a very brief answer. 0.26. What is the average Rent(as % of GDP) of Upper middle income per year?
Give a very brief answer. 1.26. What is the average Rent(as % of GDP) of United Kingdom per year?
Your answer should be very brief. 0.6. What is the average Rent(as % of GDP) in United States per year?
Offer a terse response. 0.53. In the year 2002, what is the difference between the Rent(as % of GDP) in European Union and Rent(as % of GDP) in Upper middle income?
Provide a short and direct response. -0.57. In the year 2002, what is the difference between the Rent(as % of GDP) of European Union and Rent(as % of GDP) of United Kingdom?
Your answer should be very brief. -0.27. In the year 2002, what is the difference between the Rent(as % of GDP) of European Union and Rent(as % of GDP) of United States?
Make the answer very short. -0.02. In the year 2002, what is the difference between the Rent(as % of GDP) of Upper middle income and Rent(as % of GDP) of United Kingdom?
Provide a succinct answer. 0.3. In the year 2002, what is the difference between the Rent(as % of GDP) in Upper middle income and Rent(as % of GDP) in United States?
Provide a short and direct response. 0.55. In the year 2002, what is the difference between the Rent(as % of GDP) in United Kingdom and Rent(as % of GDP) in United States?
Your answer should be very brief. 0.25. In the year 2003, what is the difference between the Rent(as % of GDP) of European Union and Rent(as % of GDP) of Upper middle income?
Your response must be concise. -0.93. In the year 2003, what is the difference between the Rent(as % of GDP) of European Union and Rent(as % of GDP) of United Kingdom?
Give a very brief answer. -0.41. In the year 2003, what is the difference between the Rent(as % of GDP) in European Union and Rent(as % of GDP) in United States?
Make the answer very short. -0.19. In the year 2003, what is the difference between the Rent(as % of GDP) in Upper middle income and Rent(as % of GDP) in United Kingdom?
Your answer should be very brief. 0.51. In the year 2003, what is the difference between the Rent(as % of GDP) in Upper middle income and Rent(as % of GDP) in United States?
Offer a very short reply. 0.74. In the year 2003, what is the difference between the Rent(as % of GDP) of United Kingdom and Rent(as % of GDP) of United States?
Your response must be concise. 0.22. In the year 2004, what is the difference between the Rent(as % of GDP) in European Union and Rent(as % of GDP) in Upper middle income?
Provide a succinct answer. -0.94. In the year 2004, what is the difference between the Rent(as % of GDP) in European Union and Rent(as % of GDP) in United Kingdom?
Give a very brief answer. -0.34. In the year 2004, what is the difference between the Rent(as % of GDP) in European Union and Rent(as % of GDP) in United States?
Make the answer very short. -0.2. In the year 2004, what is the difference between the Rent(as % of GDP) in Upper middle income and Rent(as % of GDP) in United Kingdom?
Make the answer very short. 0.6. In the year 2004, what is the difference between the Rent(as % of GDP) of Upper middle income and Rent(as % of GDP) of United States?
Provide a succinct answer. 0.74. In the year 2004, what is the difference between the Rent(as % of GDP) of United Kingdom and Rent(as % of GDP) of United States?
Ensure brevity in your answer.  0.14. In the year 2005, what is the difference between the Rent(as % of GDP) in European Union and Rent(as % of GDP) in Upper middle income?
Offer a terse response. -1.38. In the year 2005, what is the difference between the Rent(as % of GDP) of European Union and Rent(as % of GDP) of United Kingdom?
Your response must be concise. -0.46. In the year 2005, what is the difference between the Rent(as % of GDP) in European Union and Rent(as % of GDP) in United States?
Give a very brief answer. -0.36. In the year 2005, what is the difference between the Rent(as % of GDP) of Upper middle income and Rent(as % of GDP) of United Kingdom?
Ensure brevity in your answer.  0.92. In the year 2005, what is the difference between the Rent(as % of GDP) of Upper middle income and Rent(as % of GDP) of United States?
Ensure brevity in your answer.  1.02. In the year 2005, what is the difference between the Rent(as % of GDP) in United Kingdom and Rent(as % of GDP) in United States?
Offer a very short reply. 0.09. In the year 2006, what is the difference between the Rent(as % of GDP) of European Union and Rent(as % of GDP) of Upper middle income?
Your response must be concise. -1.17. In the year 2006, what is the difference between the Rent(as % of GDP) in European Union and Rent(as % of GDP) in United Kingdom?
Keep it short and to the point. -0.35. In the year 2006, what is the difference between the Rent(as % of GDP) in European Union and Rent(as % of GDP) in United States?
Your answer should be compact. -0.33. In the year 2006, what is the difference between the Rent(as % of GDP) of Upper middle income and Rent(as % of GDP) of United Kingdom?
Your answer should be compact. 0.82. In the year 2006, what is the difference between the Rent(as % of GDP) of Upper middle income and Rent(as % of GDP) of United States?
Your response must be concise. 0.84. In the year 2006, what is the difference between the Rent(as % of GDP) of United Kingdom and Rent(as % of GDP) of United States?
Provide a succinct answer. 0.02. In the year 2007, what is the difference between the Rent(as % of GDP) in European Union and Rent(as % of GDP) in Upper middle income?
Ensure brevity in your answer.  -1.03. In the year 2007, what is the difference between the Rent(as % of GDP) in European Union and Rent(as % of GDP) in United Kingdom?
Provide a succinct answer. -0.27. In the year 2007, what is the difference between the Rent(as % of GDP) of European Union and Rent(as % of GDP) of United States?
Your answer should be compact. -0.35. In the year 2007, what is the difference between the Rent(as % of GDP) of Upper middle income and Rent(as % of GDP) of United Kingdom?
Offer a terse response. 0.76. In the year 2007, what is the difference between the Rent(as % of GDP) in Upper middle income and Rent(as % of GDP) in United States?
Your response must be concise. 0.68. In the year 2007, what is the difference between the Rent(as % of GDP) of United Kingdom and Rent(as % of GDP) of United States?
Your answer should be compact. -0.08. In the year 2008, what is the difference between the Rent(as % of GDP) in European Union and Rent(as % of GDP) in Upper middle income?
Provide a succinct answer. -1.33. In the year 2008, what is the difference between the Rent(as % of GDP) in European Union and Rent(as % of GDP) in United Kingdom?
Your response must be concise. -0.44. In the year 2008, what is the difference between the Rent(as % of GDP) in European Union and Rent(as % of GDP) in United States?
Ensure brevity in your answer.  -0.61. In the year 2008, what is the difference between the Rent(as % of GDP) of Upper middle income and Rent(as % of GDP) of United Kingdom?
Your answer should be compact. 0.89. In the year 2008, what is the difference between the Rent(as % of GDP) of Upper middle income and Rent(as % of GDP) of United States?
Your response must be concise. 0.71. In the year 2008, what is the difference between the Rent(as % of GDP) in United Kingdom and Rent(as % of GDP) in United States?
Offer a very short reply. -0.17. In the year 2009, what is the difference between the Rent(as % of GDP) of European Union and Rent(as % of GDP) of Upper middle income?
Make the answer very short. -0.66. In the year 2009, what is the difference between the Rent(as % of GDP) of European Union and Rent(as % of GDP) of United Kingdom?
Make the answer very short. -0.19. In the year 2009, what is the difference between the Rent(as % of GDP) of European Union and Rent(as % of GDP) of United States?
Provide a short and direct response. -0.08. In the year 2009, what is the difference between the Rent(as % of GDP) in Upper middle income and Rent(as % of GDP) in United Kingdom?
Offer a terse response. 0.47. In the year 2009, what is the difference between the Rent(as % of GDP) in Upper middle income and Rent(as % of GDP) in United States?
Your answer should be very brief. 0.59. In the year 2009, what is the difference between the Rent(as % of GDP) in United Kingdom and Rent(as % of GDP) in United States?
Your response must be concise. 0.11. What is the ratio of the Rent(as % of GDP) of European Union in 2002 to that in 2003?
Make the answer very short. 0.73. What is the ratio of the Rent(as % of GDP) in Upper middle income in 2002 to that in 2003?
Give a very brief answer. 0.64. What is the ratio of the Rent(as % of GDP) of United Kingdom in 2002 to that in 2003?
Ensure brevity in your answer.  0.69. What is the ratio of the Rent(as % of GDP) of United States in 2002 to that in 2003?
Your response must be concise. 0.47. What is the ratio of the Rent(as % of GDP) in European Union in 2002 to that in 2004?
Make the answer very short. 0.76. What is the ratio of the Rent(as % of GDP) of Upper middle income in 2002 to that in 2004?
Give a very brief answer. 0.64. What is the ratio of the Rent(as % of GDP) in United Kingdom in 2002 to that in 2004?
Keep it short and to the point. 0.79. What is the ratio of the Rent(as % of GDP) of United States in 2002 to that in 2004?
Offer a terse response. 0.47. What is the ratio of the Rent(as % of GDP) in European Union in 2002 to that in 2005?
Keep it short and to the point. 0.53. What is the ratio of the Rent(as % of GDP) in Upper middle income in 2002 to that in 2005?
Provide a short and direct response. 0.44. What is the ratio of the Rent(as % of GDP) of United Kingdom in 2002 to that in 2005?
Keep it short and to the point. 0.57. What is the ratio of the Rent(as % of GDP) in United States in 2002 to that in 2005?
Offer a terse response. 0.29. What is the ratio of the Rent(as % of GDP) of European Union in 2002 to that in 2006?
Offer a very short reply. 0.62. What is the ratio of the Rent(as % of GDP) of Upper middle income in 2002 to that in 2006?
Your answer should be compact. 0.52. What is the ratio of the Rent(as % of GDP) in United Kingdom in 2002 to that in 2006?
Offer a very short reply. 0.7. What is the ratio of the Rent(as % of GDP) in United States in 2002 to that in 2006?
Your answer should be very brief. 0.33. What is the ratio of the Rent(as % of GDP) of European Union in 2002 to that in 2007?
Make the answer very short. 0.77. What is the ratio of the Rent(as % of GDP) in Upper middle income in 2002 to that in 2007?
Your answer should be very brief. 0.6. What is the ratio of the Rent(as % of GDP) in United Kingdom in 2002 to that in 2007?
Your response must be concise. 0.9. What is the ratio of the Rent(as % of GDP) in United States in 2002 to that in 2007?
Ensure brevity in your answer.  0.35. What is the ratio of the Rent(as % of GDP) of European Union in 2002 to that in 2008?
Keep it short and to the point. 0.55. What is the ratio of the Rent(as % of GDP) of Upper middle income in 2002 to that in 2008?
Your response must be concise. 0.46. What is the ratio of the Rent(as % of GDP) of United Kingdom in 2002 to that in 2008?
Give a very brief answer. 0.59. What is the ratio of the Rent(as % of GDP) in United States in 2002 to that in 2008?
Provide a succinct answer. 0.22. What is the ratio of the Rent(as % of GDP) in European Union in 2002 to that in 2009?
Make the answer very short. 1.3. What is the ratio of the Rent(as % of GDP) of Upper middle income in 2002 to that in 2009?
Make the answer very short. 0.94. What is the ratio of the Rent(as % of GDP) in United Kingdom in 2002 to that in 2009?
Offer a terse response. 1.38. What is the ratio of the Rent(as % of GDP) in United States in 2002 to that in 2009?
Ensure brevity in your answer.  0.95. What is the ratio of the Rent(as % of GDP) in European Union in 2003 to that in 2004?
Your answer should be compact. 1.04. What is the ratio of the Rent(as % of GDP) in Upper middle income in 2003 to that in 2004?
Ensure brevity in your answer.  1. What is the ratio of the Rent(as % of GDP) in United Kingdom in 2003 to that in 2004?
Your answer should be compact. 1.15. What is the ratio of the Rent(as % of GDP) in European Union in 2003 to that in 2005?
Provide a succinct answer. 0.72. What is the ratio of the Rent(as % of GDP) in Upper middle income in 2003 to that in 2005?
Make the answer very short. 0.68. What is the ratio of the Rent(as % of GDP) in United Kingdom in 2003 to that in 2005?
Your answer should be compact. 0.83. What is the ratio of the Rent(as % of GDP) of United States in 2003 to that in 2005?
Offer a very short reply. 0.62. What is the ratio of the Rent(as % of GDP) in European Union in 2003 to that in 2006?
Give a very brief answer. 0.84. What is the ratio of the Rent(as % of GDP) of Upper middle income in 2003 to that in 2006?
Your response must be concise. 0.8. What is the ratio of the Rent(as % of GDP) in United Kingdom in 2003 to that in 2006?
Ensure brevity in your answer.  1.02. What is the ratio of the Rent(as % of GDP) in United States in 2003 to that in 2006?
Offer a terse response. 0.7. What is the ratio of the Rent(as % of GDP) of European Union in 2003 to that in 2007?
Keep it short and to the point. 1.05. What is the ratio of the Rent(as % of GDP) of Upper middle income in 2003 to that in 2007?
Offer a very short reply. 0.93. What is the ratio of the Rent(as % of GDP) in United Kingdom in 2003 to that in 2007?
Your answer should be very brief. 1.31. What is the ratio of the Rent(as % of GDP) of United States in 2003 to that in 2007?
Keep it short and to the point. 0.75. What is the ratio of the Rent(as % of GDP) in European Union in 2003 to that in 2008?
Ensure brevity in your answer.  0.75. What is the ratio of the Rent(as % of GDP) in Upper middle income in 2003 to that in 2008?
Your answer should be compact. 0.71. What is the ratio of the Rent(as % of GDP) of United Kingdom in 2003 to that in 2008?
Your answer should be very brief. 0.86. What is the ratio of the Rent(as % of GDP) of United States in 2003 to that in 2008?
Your answer should be very brief. 0.47. What is the ratio of the Rent(as % of GDP) of European Union in 2003 to that in 2009?
Make the answer very short. 1.77. What is the ratio of the Rent(as % of GDP) in Upper middle income in 2003 to that in 2009?
Offer a very short reply. 1.47. What is the ratio of the Rent(as % of GDP) of United Kingdom in 2003 to that in 2009?
Provide a succinct answer. 2.01. What is the ratio of the Rent(as % of GDP) in United States in 2003 to that in 2009?
Your answer should be very brief. 2.03. What is the ratio of the Rent(as % of GDP) of European Union in 2004 to that in 2005?
Give a very brief answer. 0.7. What is the ratio of the Rent(as % of GDP) in Upper middle income in 2004 to that in 2005?
Provide a succinct answer. 0.69. What is the ratio of the Rent(as % of GDP) of United Kingdom in 2004 to that in 2005?
Make the answer very short. 0.72. What is the ratio of the Rent(as % of GDP) in United States in 2004 to that in 2005?
Give a very brief answer. 0.62. What is the ratio of the Rent(as % of GDP) in European Union in 2004 to that in 2006?
Keep it short and to the point. 0.81. What is the ratio of the Rent(as % of GDP) in Upper middle income in 2004 to that in 2006?
Make the answer very short. 0.8. What is the ratio of the Rent(as % of GDP) in United Kingdom in 2004 to that in 2006?
Offer a terse response. 0.89. What is the ratio of the Rent(as % of GDP) of United States in 2004 to that in 2006?
Give a very brief answer. 0.7. What is the ratio of the Rent(as % of GDP) in European Union in 2004 to that in 2007?
Ensure brevity in your answer.  1.01. What is the ratio of the Rent(as % of GDP) in Upper middle income in 2004 to that in 2007?
Offer a terse response. 0.93. What is the ratio of the Rent(as % of GDP) in United Kingdom in 2004 to that in 2007?
Provide a short and direct response. 1.13. What is the ratio of the Rent(as % of GDP) of United States in 2004 to that in 2007?
Provide a succinct answer. 0.75. What is the ratio of the Rent(as % of GDP) in European Union in 2004 to that in 2008?
Provide a short and direct response. 0.73. What is the ratio of the Rent(as % of GDP) of Upper middle income in 2004 to that in 2008?
Provide a short and direct response. 0.71. What is the ratio of the Rent(as % of GDP) of United Kingdom in 2004 to that in 2008?
Provide a short and direct response. 0.75. What is the ratio of the Rent(as % of GDP) of United States in 2004 to that in 2008?
Your answer should be very brief. 0.47. What is the ratio of the Rent(as % of GDP) of European Union in 2004 to that in 2009?
Give a very brief answer. 1.7. What is the ratio of the Rent(as % of GDP) of Upper middle income in 2004 to that in 2009?
Offer a very short reply. 1.47. What is the ratio of the Rent(as % of GDP) in United Kingdom in 2004 to that in 2009?
Keep it short and to the point. 1.74. What is the ratio of the Rent(as % of GDP) in United States in 2004 to that in 2009?
Your response must be concise. 2.02. What is the ratio of the Rent(as % of GDP) of European Union in 2005 to that in 2006?
Keep it short and to the point. 1.16. What is the ratio of the Rent(as % of GDP) in Upper middle income in 2005 to that in 2006?
Your response must be concise. 1.17. What is the ratio of the Rent(as % of GDP) of United Kingdom in 2005 to that in 2006?
Your answer should be very brief. 1.23. What is the ratio of the Rent(as % of GDP) in United States in 2005 to that in 2006?
Keep it short and to the point. 1.13. What is the ratio of the Rent(as % of GDP) in European Union in 2005 to that in 2007?
Offer a very short reply. 1.44. What is the ratio of the Rent(as % of GDP) of Upper middle income in 2005 to that in 2007?
Keep it short and to the point. 1.36. What is the ratio of the Rent(as % of GDP) of United Kingdom in 2005 to that in 2007?
Offer a terse response. 1.58. What is the ratio of the Rent(as % of GDP) in United States in 2005 to that in 2007?
Make the answer very short. 1.2. What is the ratio of the Rent(as % of GDP) of European Union in 2005 to that in 2008?
Provide a succinct answer. 1.04. What is the ratio of the Rent(as % of GDP) in Upper middle income in 2005 to that in 2008?
Your answer should be compact. 1.04. What is the ratio of the Rent(as % of GDP) in United Kingdom in 2005 to that in 2008?
Ensure brevity in your answer.  1.04. What is the ratio of the Rent(as % of GDP) in United States in 2005 to that in 2008?
Provide a succinct answer. 0.75. What is the ratio of the Rent(as % of GDP) in European Union in 2005 to that in 2009?
Your response must be concise. 2.44. What is the ratio of the Rent(as % of GDP) of Upper middle income in 2005 to that in 2009?
Offer a terse response. 2.15. What is the ratio of the Rent(as % of GDP) in United Kingdom in 2005 to that in 2009?
Ensure brevity in your answer.  2.43. What is the ratio of the Rent(as % of GDP) of United States in 2005 to that in 2009?
Your answer should be very brief. 3.25. What is the ratio of the Rent(as % of GDP) of European Union in 2006 to that in 2007?
Make the answer very short. 1.24. What is the ratio of the Rent(as % of GDP) in Upper middle income in 2006 to that in 2007?
Provide a short and direct response. 1.16. What is the ratio of the Rent(as % of GDP) of United Kingdom in 2006 to that in 2007?
Make the answer very short. 1.28. What is the ratio of the Rent(as % of GDP) in United States in 2006 to that in 2007?
Offer a terse response. 1.07. What is the ratio of the Rent(as % of GDP) in European Union in 2006 to that in 2008?
Give a very brief answer. 0.9. What is the ratio of the Rent(as % of GDP) of Upper middle income in 2006 to that in 2008?
Your answer should be compact. 0.89. What is the ratio of the Rent(as % of GDP) in United Kingdom in 2006 to that in 2008?
Offer a terse response. 0.84. What is the ratio of the Rent(as % of GDP) in United States in 2006 to that in 2008?
Ensure brevity in your answer.  0.67. What is the ratio of the Rent(as % of GDP) in European Union in 2006 to that in 2009?
Offer a terse response. 2.1. What is the ratio of the Rent(as % of GDP) of Upper middle income in 2006 to that in 2009?
Your answer should be very brief. 1.83. What is the ratio of the Rent(as % of GDP) in United Kingdom in 2006 to that in 2009?
Give a very brief answer. 1.97. What is the ratio of the Rent(as % of GDP) in United States in 2006 to that in 2009?
Offer a very short reply. 2.88. What is the ratio of the Rent(as % of GDP) of European Union in 2007 to that in 2008?
Keep it short and to the point. 0.72. What is the ratio of the Rent(as % of GDP) of Upper middle income in 2007 to that in 2008?
Make the answer very short. 0.76. What is the ratio of the Rent(as % of GDP) in United Kingdom in 2007 to that in 2008?
Your answer should be compact. 0.66. What is the ratio of the Rent(as % of GDP) of United States in 2007 to that in 2008?
Your answer should be very brief. 0.62. What is the ratio of the Rent(as % of GDP) of European Union in 2007 to that in 2009?
Give a very brief answer. 1.69. What is the ratio of the Rent(as % of GDP) of Upper middle income in 2007 to that in 2009?
Give a very brief answer. 1.58. What is the ratio of the Rent(as % of GDP) of United Kingdom in 2007 to that in 2009?
Your response must be concise. 1.53. What is the ratio of the Rent(as % of GDP) of United States in 2007 to that in 2009?
Your answer should be compact. 2.7. What is the ratio of the Rent(as % of GDP) of European Union in 2008 to that in 2009?
Offer a terse response. 2.35. What is the ratio of the Rent(as % of GDP) in Upper middle income in 2008 to that in 2009?
Offer a very short reply. 2.07. What is the ratio of the Rent(as % of GDP) in United Kingdom in 2008 to that in 2009?
Offer a terse response. 2.34. What is the ratio of the Rent(as % of GDP) in United States in 2008 to that in 2009?
Offer a very short reply. 4.33. What is the difference between the highest and the second highest Rent(as % of GDP) of European Union?
Make the answer very short. 0.01. What is the difference between the highest and the second highest Rent(as % of GDP) of Upper middle income?
Your answer should be very brief. 0.07. What is the difference between the highest and the second highest Rent(as % of GDP) of United Kingdom?
Your answer should be very brief. 0.03. What is the difference between the highest and the second highest Rent(as % of GDP) in United States?
Offer a very short reply. 0.24. What is the difference between the highest and the lowest Rent(as % of GDP) of European Union?
Your answer should be compact. 0.21. What is the difference between the highest and the lowest Rent(as % of GDP) of Upper middle income?
Give a very brief answer. 0.97. What is the difference between the highest and the lowest Rent(as % of GDP) in United Kingdom?
Provide a short and direct response. 0.48. What is the difference between the highest and the lowest Rent(as % of GDP) in United States?
Keep it short and to the point. 0.74. 